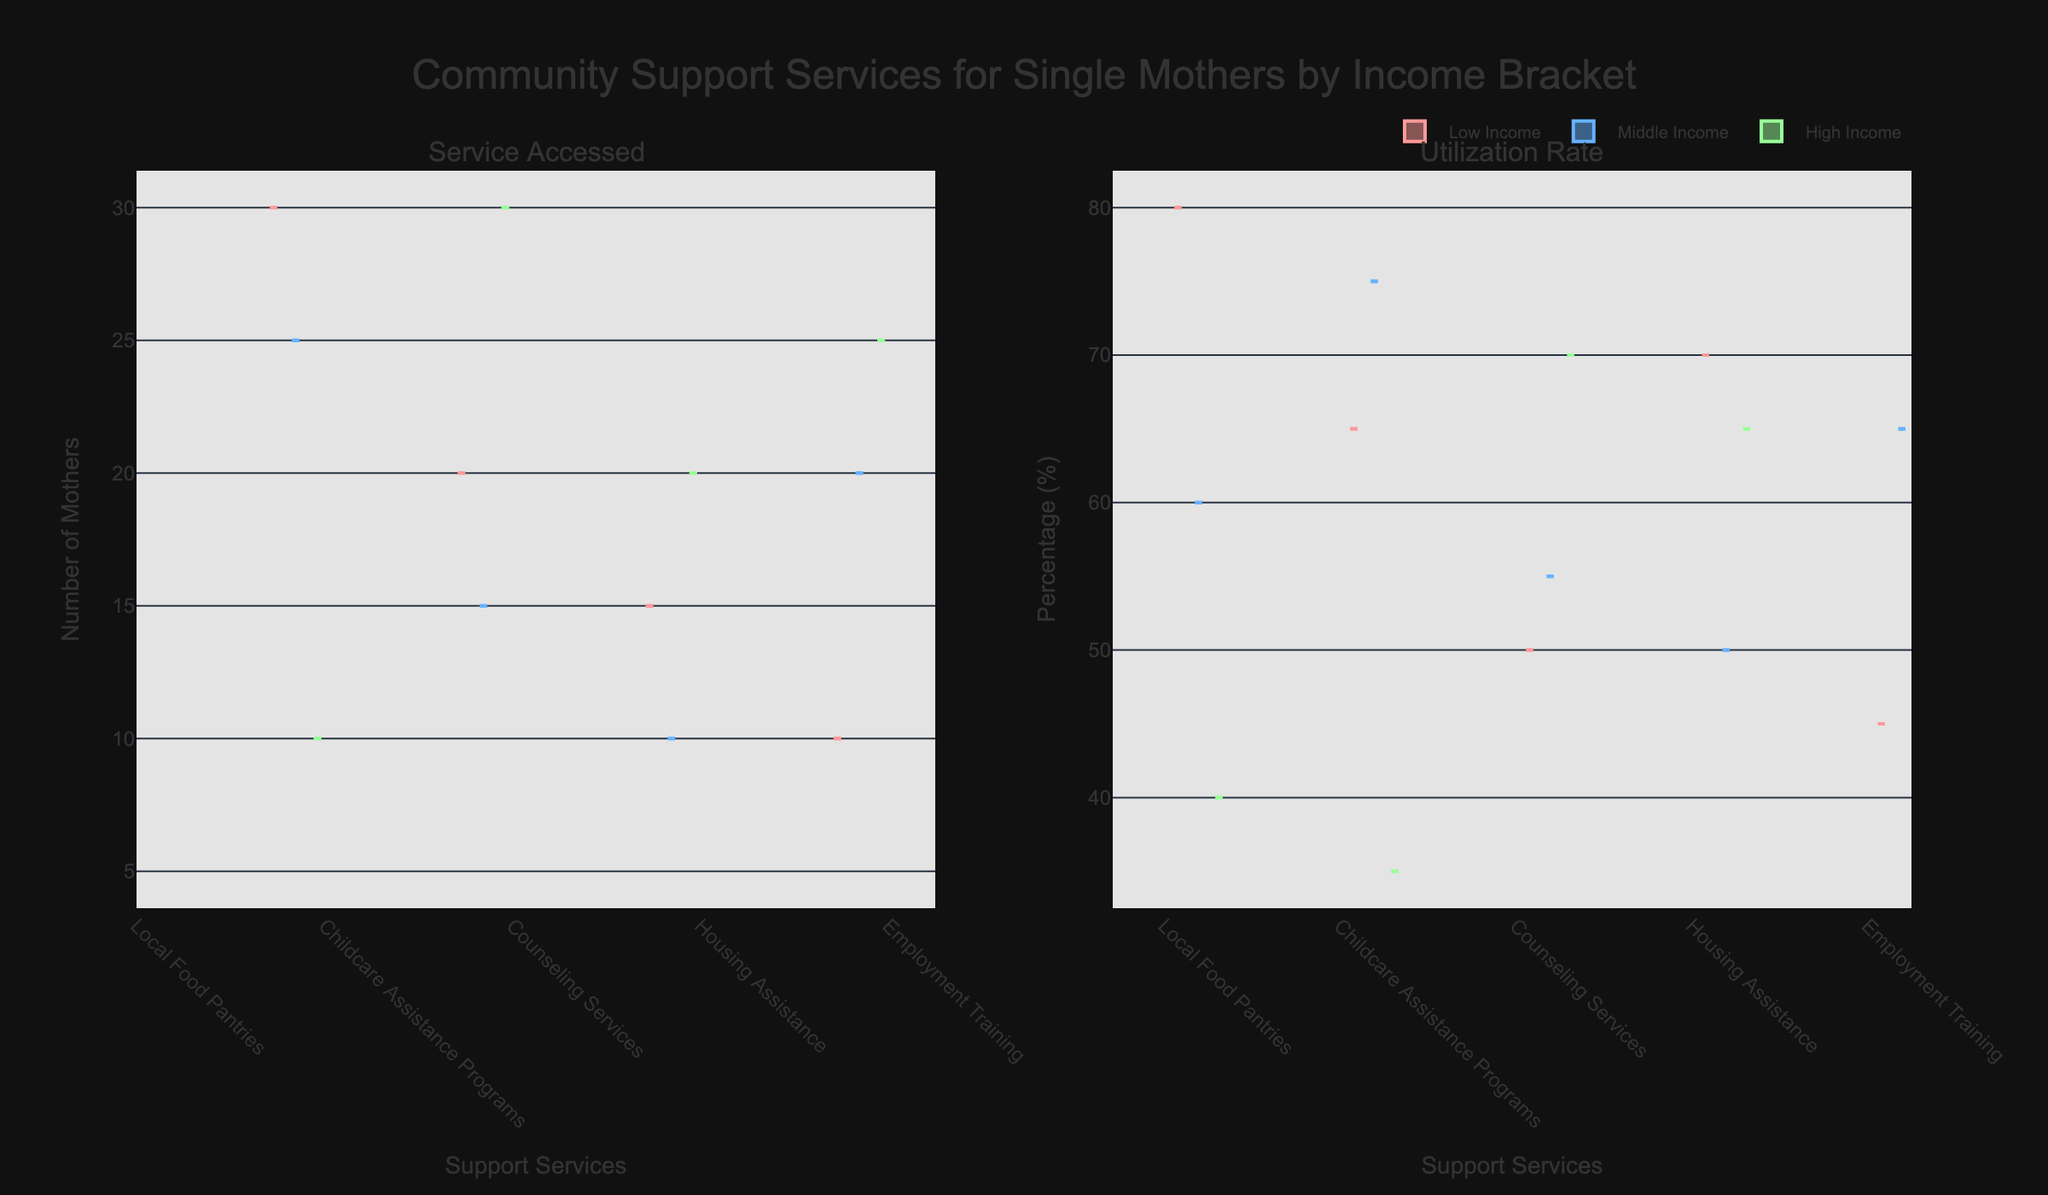Which support service shows the highest utilization rate among low-income single mothers? Looking at the "Utilization Rate" subplot and the data points corresponding to low-income, the highest utilization rate is 80%, which pertains to Local Food Pantries.
Answer: Local Food Pantries How does the median number of services accessed by high-income single mothers compare to those from middle-income households? Observe the "Service Accessed" subplot for high-income mothers and note the median line for each group. The median number of services accessed by high-income single mothers is lower compared to middle-income mothers, who access more services.
Answer: Lower What is the utilization rate for counseling services among high-income single mothers? In the "Utilization Rate" subplot, look for the data points associated with high-income mothers and check the value for Counseling Services, which is 70%.
Answer: 70% Which income group utilizes housing assistance the most? Comparing the utilization rates for Housing Assistance across all income brackets in the "Utilization Rate" subplot, low-income single mothers have the highest utilization rate at 70%.
Answer: Low-income Do local food pantries have a higher number of services accessed by low-income mothers compared to high-income mothers? In the "Service Accessed" subplot, compare the data points for Local Food Pantries accessed by low-income and high-income single mothers. Low-income mothers access it more, with 25 versus 5.
Answer: Yes Which community support service shows the most significant difference in utilization rates between low-income and high-income mothers? Calculate the differences in utilization rates between low- and high-income mothers for each service. Childcare Assistance Programs have the most significant difference, with 65% (low-income) vs 35% (high-income), i.e., 30%.
Answer: Childcare Assistance Programs How many support services have a utilization rate of over 60% among middle-income mothers? From the "Utilization Rate" subplot, count the number of services accessed by middle-income mothers that show utilization rates over 60%. There are two services: Childcare Assistance Programs (75%) and Employment Training (65%).
Answer: Two Do middle-income mothers access more or fewer employment training services compared to low-income mothers? In the "Service Accessed" subplot, middle-income mothers have accessed 20 employment training services, while low-income mothers have accessed 10. Middle-income mothers access more employment training services.
Answer: More 